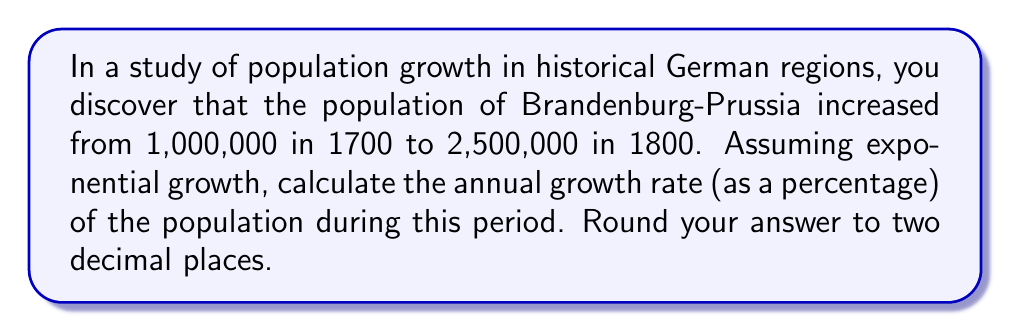Provide a solution to this math problem. To solve this problem, we'll use the exponential growth formula:

$$A = P(1 + r)^t$$

Where:
$A$ = Final amount (2,500,000)
$P$ = Initial amount (1,000,000)
$r$ = Annual growth rate (decimal form)
$t$ = Time period (100 years)

1. Substitute the known values into the formula:
   $$2,500,000 = 1,000,000(1 + r)^{100}$$

2. Divide both sides by 1,000,000:
   $$2.5 = (1 + r)^{100}$$

3. Take the 100th root of both sides:
   $$\sqrt[100]{2.5} = 1 + r$$

4. Subtract 1 from both sides:
   $$\sqrt[100]{2.5} - 1 = r$$

5. Calculate the value:
   $$r \approx 0.00924$$

6. Convert to a percentage by multiplying by 100:
   $$0.00924 \times 100 \approx 0.924\%$$

7. Round to two decimal places:
   $$0.92\%$$
Answer: $0.92\%$ 